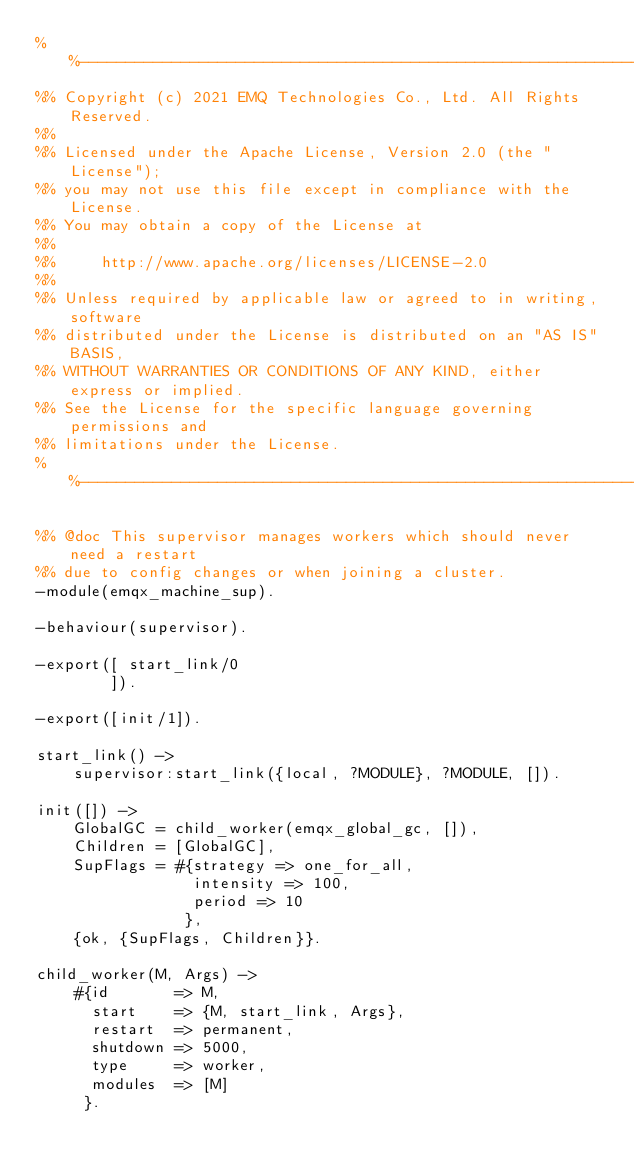Convert code to text. <code><loc_0><loc_0><loc_500><loc_500><_Erlang_>%%--------------------------------------------------------------------
%% Copyright (c) 2021 EMQ Technologies Co., Ltd. All Rights Reserved.
%%
%% Licensed under the Apache License, Version 2.0 (the "License");
%% you may not use this file except in compliance with the License.
%% You may obtain a copy of the License at
%%
%%     http://www.apache.org/licenses/LICENSE-2.0
%%
%% Unless required by applicable law or agreed to in writing, software
%% distributed under the License is distributed on an "AS IS" BASIS,
%% WITHOUT WARRANTIES OR CONDITIONS OF ANY KIND, either express or implied.
%% See the License for the specific language governing permissions and
%% limitations under the License.
%%--------------------------------------------------------------------

%% @doc This supervisor manages workers which should never need a restart
%% due to config changes or when joining a cluster.
-module(emqx_machine_sup).

-behaviour(supervisor).

-export([ start_link/0
        ]).

-export([init/1]).

start_link() ->
    supervisor:start_link({local, ?MODULE}, ?MODULE, []).

init([]) ->
    GlobalGC = child_worker(emqx_global_gc, []),
    Children = [GlobalGC],
    SupFlags = #{strategy => one_for_all,
                 intensity => 100,
                 period => 10
                },
    {ok, {SupFlags, Children}}.

child_worker(M, Args) ->
    #{id       => M,
      start    => {M, start_link, Args},
      restart  => permanent,
      shutdown => 5000,
      type     => worker,
      modules  => [M]
     }.
</code> 